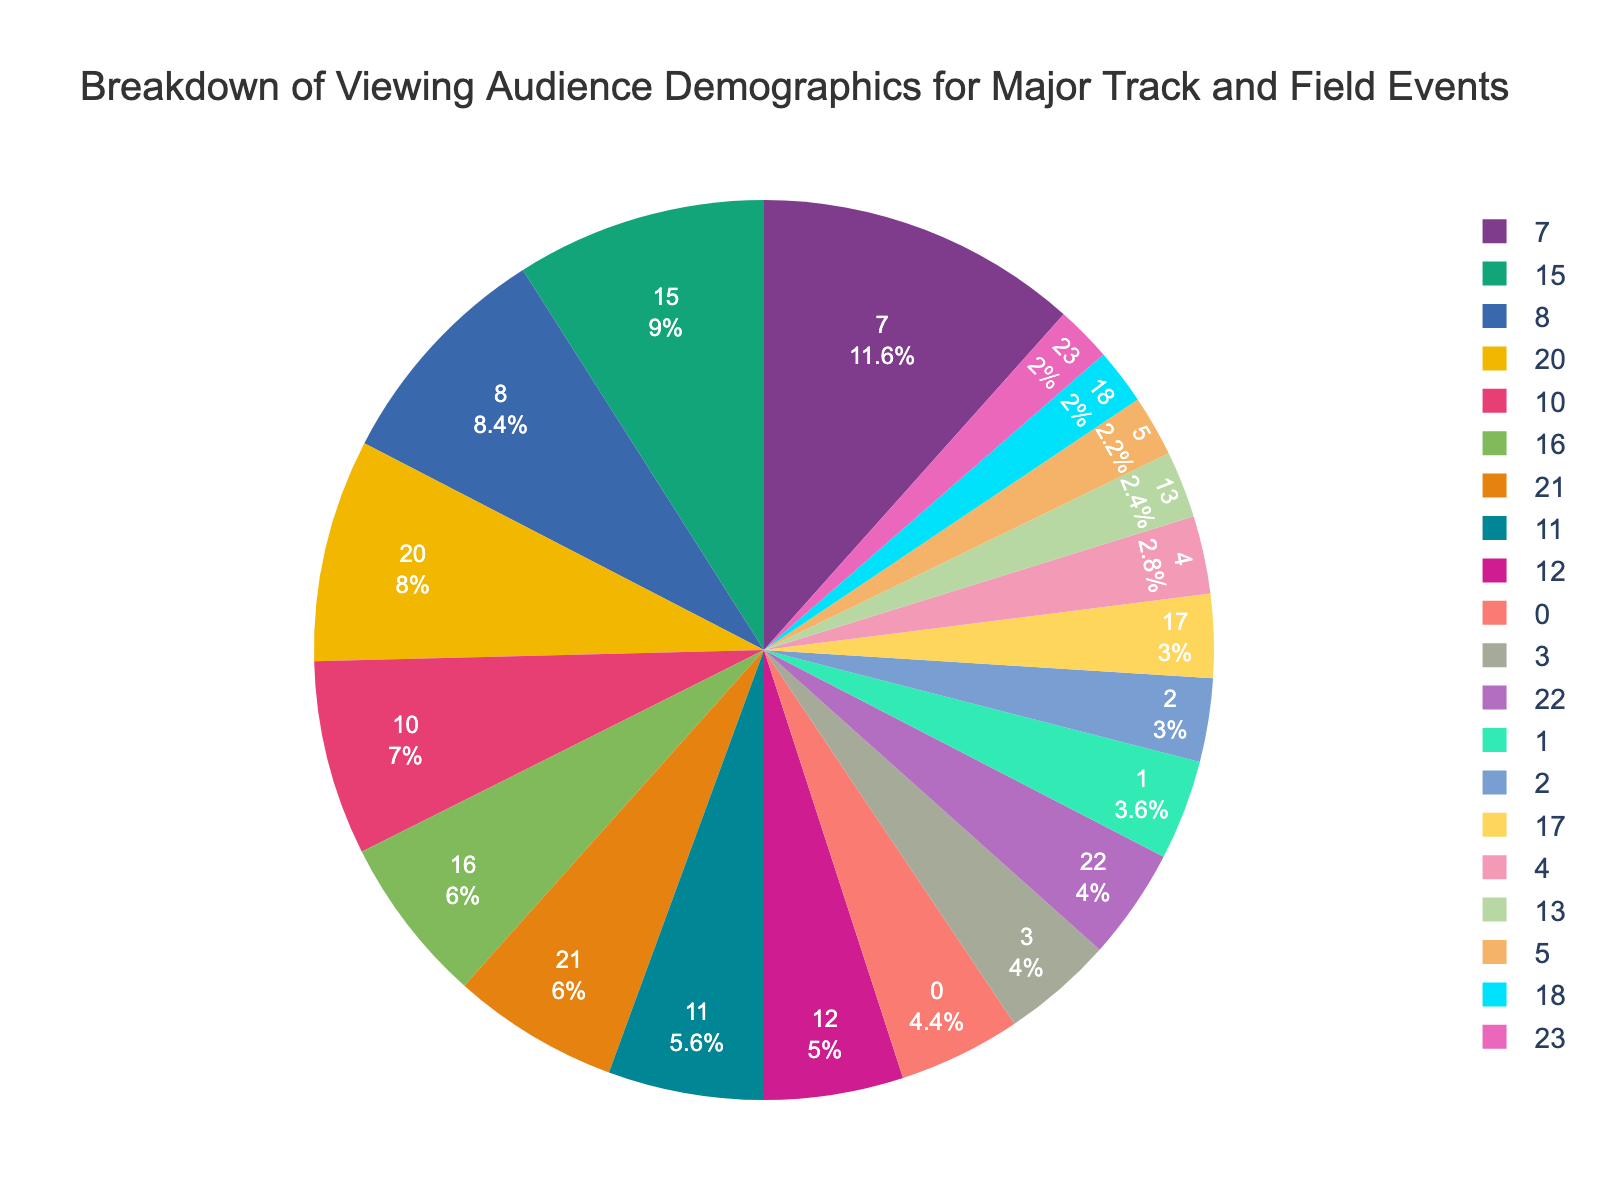What percentage of viewers are aged 18-24? The pie chart shows the Breakdown of viewing audience demographics, and we look for the portion labeled "18-24" to identify the percentage value.
Answer: 22% Which age group has the smallest percentage of the viewing audience? By examining the slices corresponding to age groups, we see that "65+" has the smallest segment.
Answer: 11% Calculate the combined percentage of viewers aged 35-54. Sum the percentage of viewers aged 35-44 and 45-54: 15% + 20% = 35%.
Answer: 35% Compare the percentage of male and female viewers. Which group has a higher percentage? Look at the segments for "Male" and "Female" and compare their sizes. "Male" has 58%, which is higher than "Female" with 42%.
Answer: Male What is the difference in percentage between Running Enthusiasts and Former Athletes? Subtract the percentage of Former Athletes from Running Enthusiasts: 30% - 10% = 20%.
Answer: 20% Among the education levels, which segment is the largest? Identify the segment with the largest size under the "Education Level" category. "High School" has the largest at 35%.
Answer: High School What percentage of viewers use social media as their viewing platform? Look at the segment labeled "Social Media" to find the percentage value.
Answer: 15% Which two age groups combined account for more than 40% of the viewing audience? Summing the largest age groups until the combined total exceeds 40%. 18-24 (22%) + 45-54 (20%) = 42%.
Answer: 18-24 and 45-54 What is the median percentage for interest levels among viewers? Arrange the interest level percentages in ascending order: 10%, 20%, 30%, 40%. Since there are four values, the median will be the average of the two middle values: (20% + 30%) / 2 = 25%.
Answer: 25% Which age group has a percentage closest to that of viewers with Bachelor's degrees? Compare the age group percentages to the Bachelor's Degree percentage (25%). The closest age group percentage is 18-24 with 22%.
Answer: 18-24 